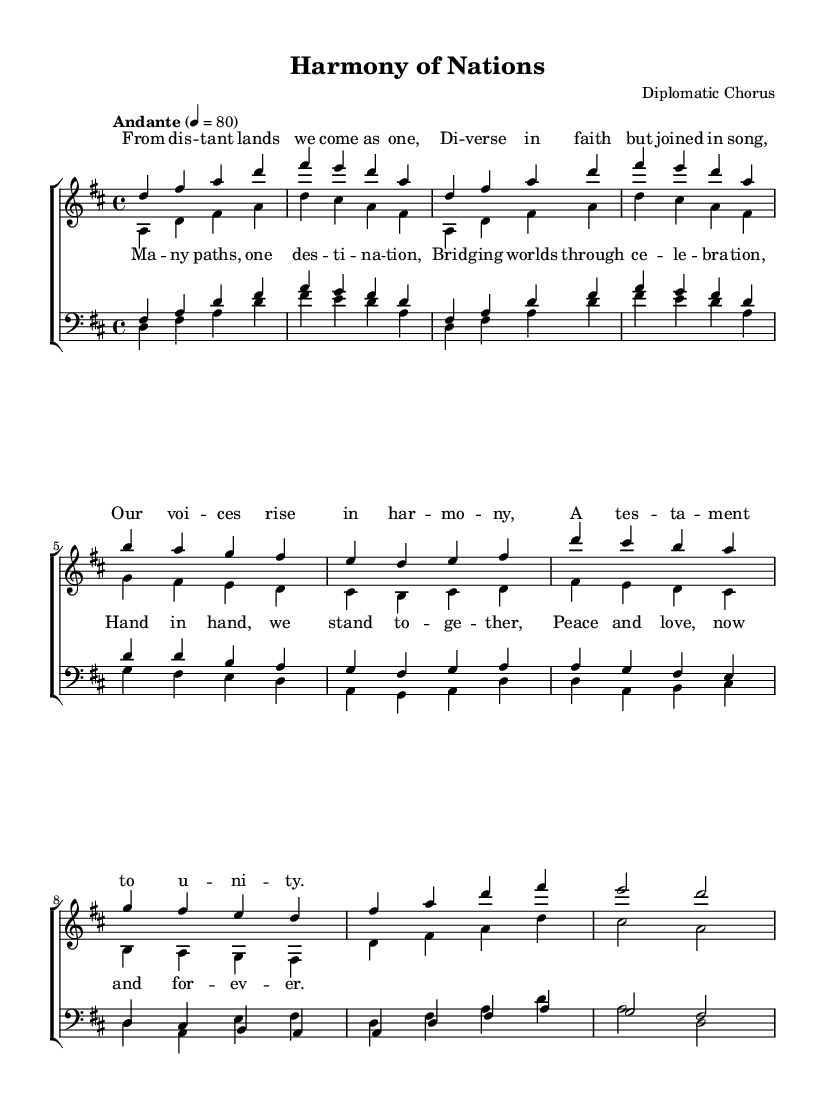What is the key signature of this music? The key signature is D major, which has two sharps (F# and C#).
Answer: D major What is the time signature of this piece? The time signature shown in the music is 4/4, indicating four beats per measure.
Answer: 4/4 What is the tempo marking for this composition? The tempo marking indicates "Andante," which is a moderate speed, typically around 76-108 beats per minute.
Answer: Andante How many voices are included in the choral arrangement? The arrangement includes four voices: soprano, alto, tenor, and bass.
Answer: Four voices What is the main theme expressed in the lyrics of the verse? The lyrics emphasize unity and coming together in harmony, regardless of diverse backgrounds.
Answer: Unity What musical elements are used to convey the theme of cultural unity? The composition uses harmony, counterpoint, and lyrical text that speaks of shared values and peace.
Answer: Harmony and lyrics Which section provides a chorus in this piece? The chorus is indicated after the first verse, formatted separately with the same melodic lines showcasing collective voices.
Answer: Chorus 